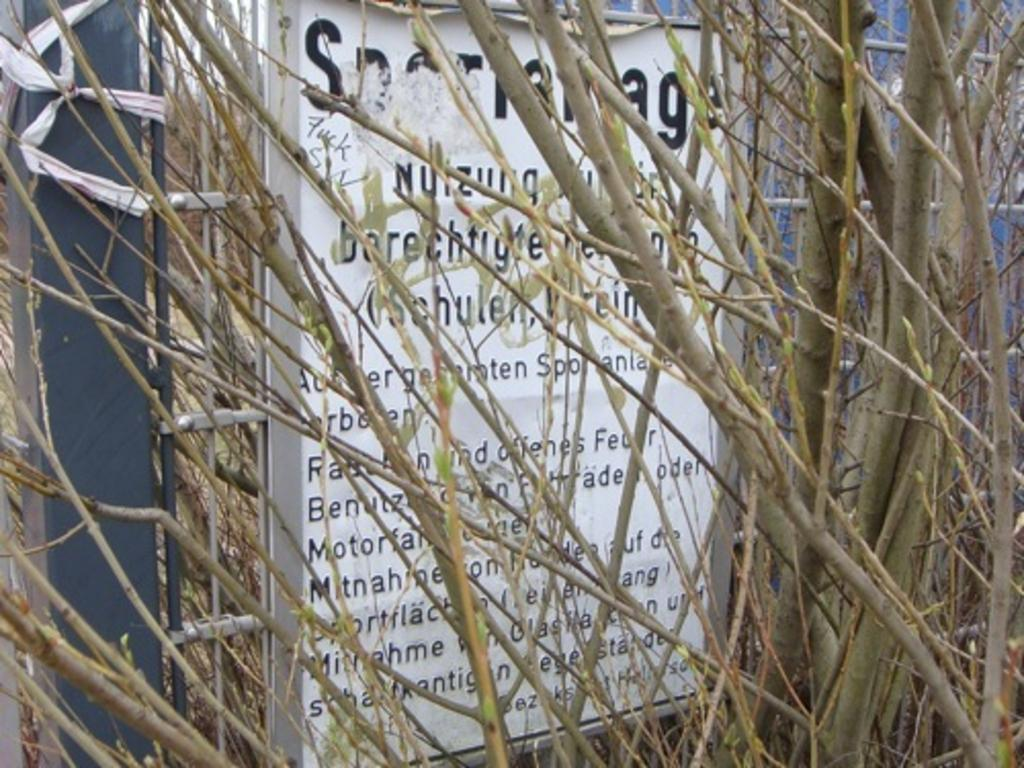What is the main subject of the image? The main subject of the image is a plant without leaves. What is located behind the plant in the image? There is a white board behind the plant. What can be seen on the white board? The white board has some information on it. What type of curtain is hanging in front of the plant in the image? There is no curtain present in the image; it features a plant without leaves and a white board behind it. What idea is being discussed on the white board in the image? The information on the white board cannot be determined from the image alone, as it is not legible. 